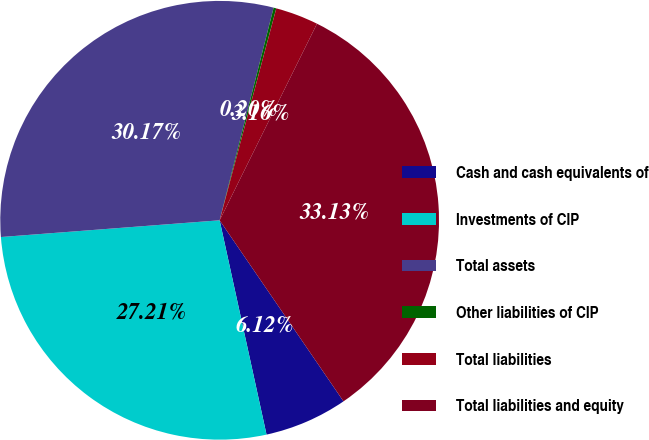Convert chart. <chart><loc_0><loc_0><loc_500><loc_500><pie_chart><fcel>Cash and cash equivalents of<fcel>Investments of CIP<fcel>Total assets<fcel>Other liabilities of CIP<fcel>Total liabilities<fcel>Total liabilities and equity<nl><fcel>6.12%<fcel>27.21%<fcel>30.17%<fcel>0.2%<fcel>3.16%<fcel>33.13%<nl></chart> 